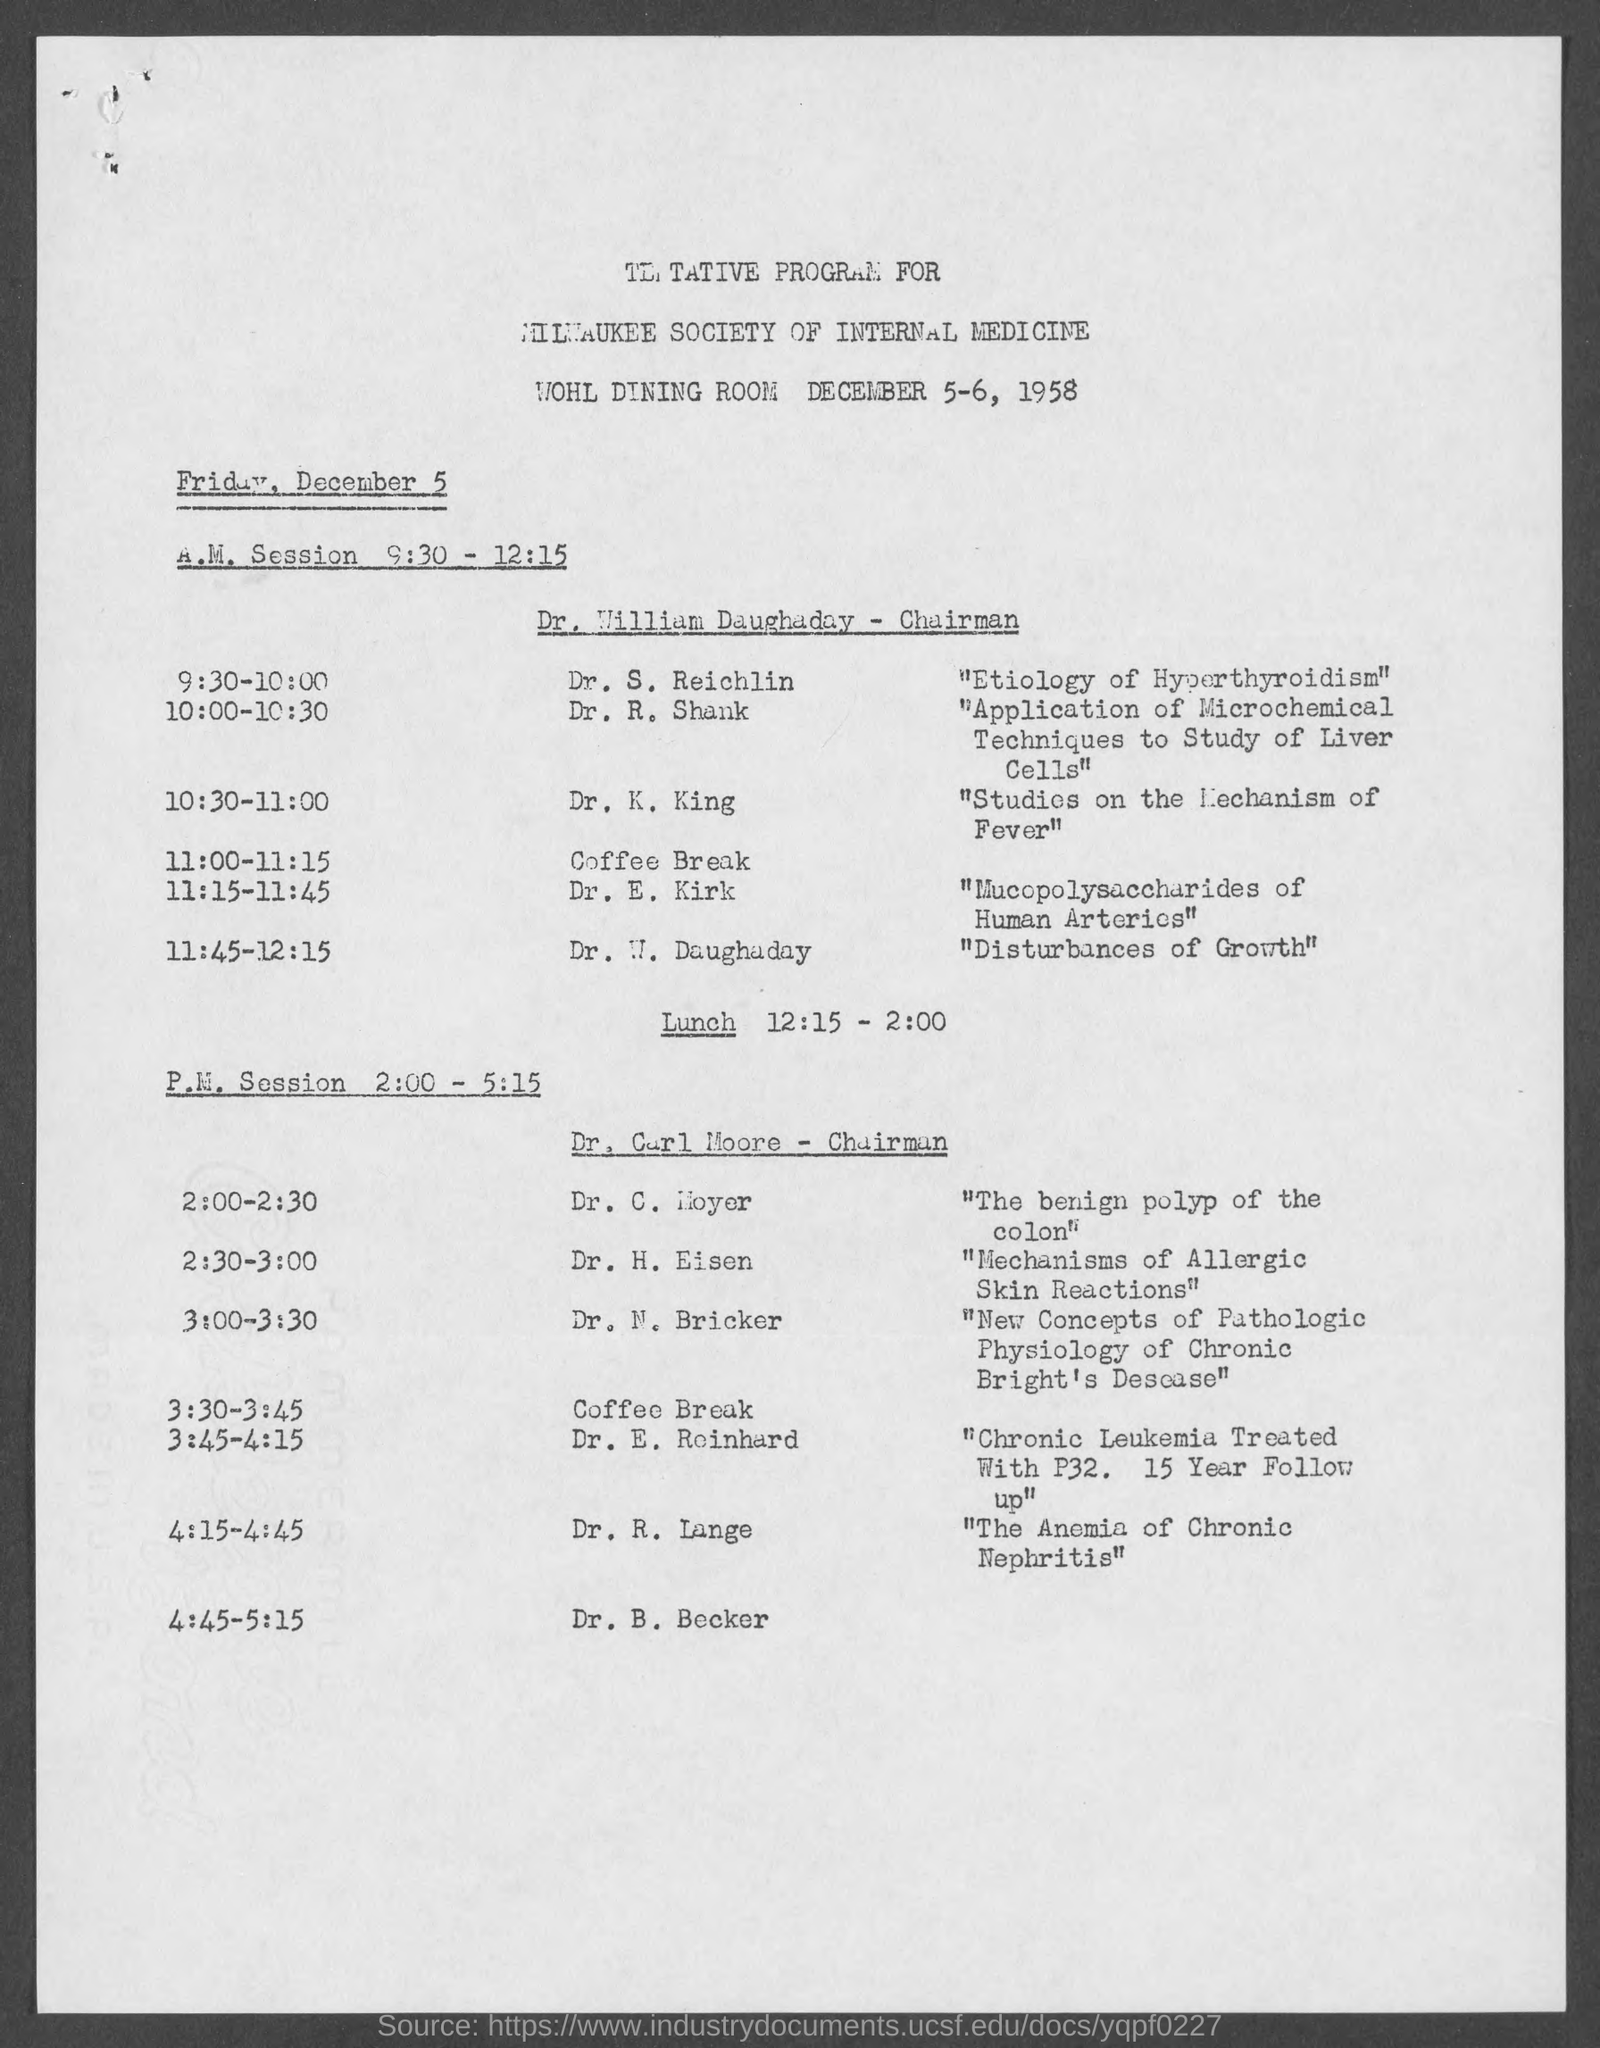When is the program going to be held?
Provide a succinct answer. DECEMBER 5-6, 1958. Who is the chairman for A.M. Session from 9:30 - 12:15 on December 5?
Your answer should be very brief. Dr. William Daughaday. At what time is the P.M. Session on December 5?
Ensure brevity in your answer.  2:00 - 5:15. What is the topic from 9:30 - 10:00?
Offer a very short reply. "Etiology of Hyperthyroidism". Who is talking from 11:15 - 11:45?
Give a very brief answer. Dr. E. Kirk. Who is speaking on "The Anemia of Chronic Nephritis"?
Ensure brevity in your answer.  Dr. r. lange. What is Dr. H. Eisen's topic?
Provide a succinct answer. "Mechanisms of Allergic Skin Reactions". Where is the program going to be held?
Keep it short and to the point. WOHL DINING ROOM. 